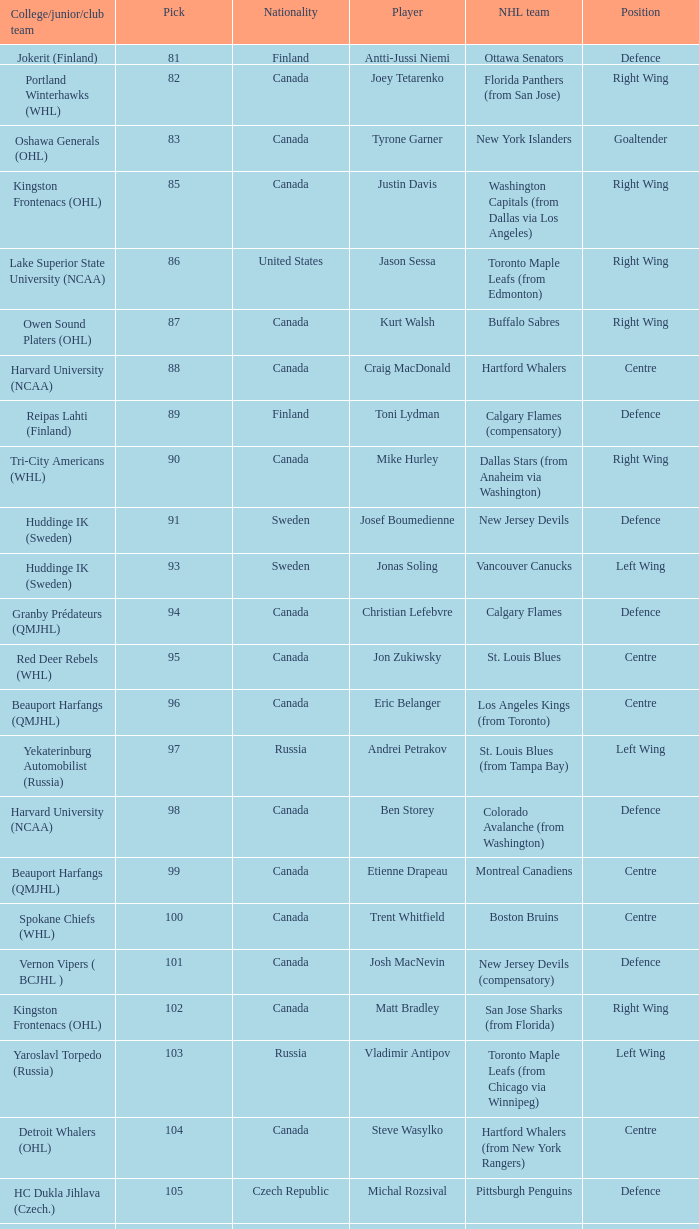How many players came from college team reipas lahti (finland)? 1.0. 